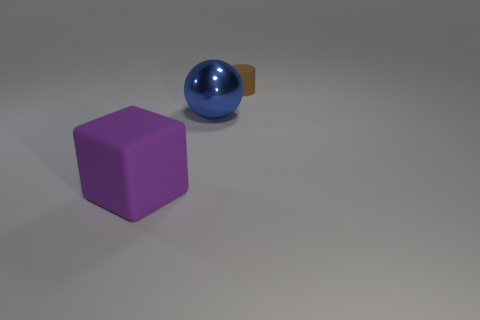Subtract 0 red balls. How many objects are left? 3 Subtract all cubes. How many objects are left? 2 Subtract all cyan balls. Subtract all purple cylinders. How many balls are left? 1 Subtract all purple matte things. Subtract all big gray cylinders. How many objects are left? 2 Add 1 tiny rubber cylinders. How many tiny rubber cylinders are left? 2 Add 1 large balls. How many large balls exist? 2 Add 3 big red rubber cubes. How many objects exist? 6 